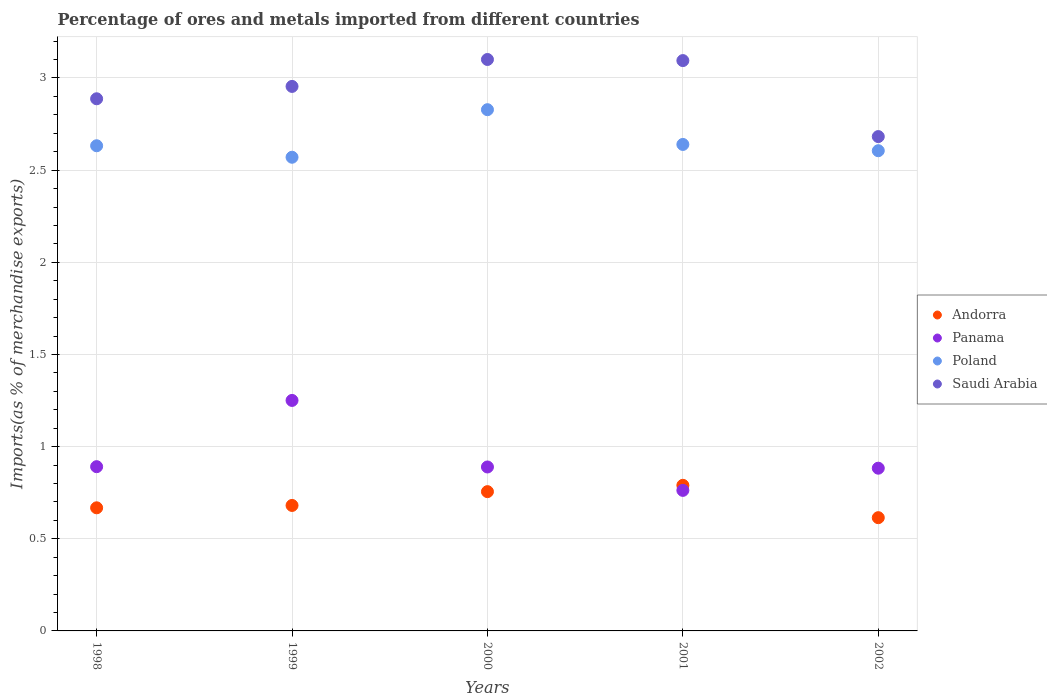What is the percentage of imports to different countries in Andorra in 2000?
Offer a terse response. 0.76. Across all years, what is the maximum percentage of imports to different countries in Saudi Arabia?
Offer a terse response. 3.1. Across all years, what is the minimum percentage of imports to different countries in Panama?
Offer a terse response. 0.76. In which year was the percentage of imports to different countries in Panama maximum?
Ensure brevity in your answer.  1999. What is the total percentage of imports to different countries in Poland in the graph?
Your response must be concise. 13.28. What is the difference between the percentage of imports to different countries in Andorra in 1999 and that in 2002?
Your answer should be compact. 0.07. What is the difference between the percentage of imports to different countries in Saudi Arabia in 1998 and the percentage of imports to different countries in Panama in 2002?
Offer a terse response. 2. What is the average percentage of imports to different countries in Saudi Arabia per year?
Keep it short and to the point. 2.94. In the year 2000, what is the difference between the percentage of imports to different countries in Panama and percentage of imports to different countries in Saudi Arabia?
Offer a terse response. -2.21. In how many years, is the percentage of imports to different countries in Poland greater than 2.5 %?
Your answer should be compact. 5. What is the ratio of the percentage of imports to different countries in Andorra in 1999 to that in 2000?
Your response must be concise. 0.9. Is the percentage of imports to different countries in Andorra in 2000 less than that in 2002?
Provide a short and direct response. No. What is the difference between the highest and the second highest percentage of imports to different countries in Poland?
Make the answer very short. 0.19. What is the difference between the highest and the lowest percentage of imports to different countries in Panama?
Offer a very short reply. 0.49. In how many years, is the percentage of imports to different countries in Panama greater than the average percentage of imports to different countries in Panama taken over all years?
Make the answer very short. 1. How many dotlines are there?
Give a very brief answer. 4. How many years are there in the graph?
Ensure brevity in your answer.  5. What is the difference between two consecutive major ticks on the Y-axis?
Your answer should be very brief. 0.5. Does the graph contain any zero values?
Offer a terse response. No. Does the graph contain grids?
Provide a short and direct response. Yes. Where does the legend appear in the graph?
Make the answer very short. Center right. How many legend labels are there?
Give a very brief answer. 4. What is the title of the graph?
Provide a short and direct response. Percentage of ores and metals imported from different countries. Does "Somalia" appear as one of the legend labels in the graph?
Offer a very short reply. No. What is the label or title of the X-axis?
Your answer should be very brief. Years. What is the label or title of the Y-axis?
Keep it short and to the point. Imports(as % of merchandise exports). What is the Imports(as % of merchandise exports) in Andorra in 1998?
Your answer should be very brief. 0.67. What is the Imports(as % of merchandise exports) of Panama in 1998?
Your answer should be very brief. 0.89. What is the Imports(as % of merchandise exports) of Poland in 1998?
Your response must be concise. 2.63. What is the Imports(as % of merchandise exports) of Saudi Arabia in 1998?
Offer a very short reply. 2.89. What is the Imports(as % of merchandise exports) in Andorra in 1999?
Your response must be concise. 0.68. What is the Imports(as % of merchandise exports) in Panama in 1999?
Your answer should be compact. 1.25. What is the Imports(as % of merchandise exports) in Poland in 1999?
Make the answer very short. 2.57. What is the Imports(as % of merchandise exports) in Saudi Arabia in 1999?
Provide a succinct answer. 2.95. What is the Imports(as % of merchandise exports) of Andorra in 2000?
Your response must be concise. 0.76. What is the Imports(as % of merchandise exports) in Panama in 2000?
Your answer should be compact. 0.89. What is the Imports(as % of merchandise exports) in Poland in 2000?
Provide a short and direct response. 2.83. What is the Imports(as % of merchandise exports) of Saudi Arabia in 2000?
Provide a succinct answer. 3.1. What is the Imports(as % of merchandise exports) of Andorra in 2001?
Your answer should be compact. 0.79. What is the Imports(as % of merchandise exports) in Panama in 2001?
Offer a terse response. 0.76. What is the Imports(as % of merchandise exports) in Poland in 2001?
Ensure brevity in your answer.  2.64. What is the Imports(as % of merchandise exports) in Saudi Arabia in 2001?
Provide a short and direct response. 3.09. What is the Imports(as % of merchandise exports) of Andorra in 2002?
Ensure brevity in your answer.  0.61. What is the Imports(as % of merchandise exports) in Panama in 2002?
Your answer should be very brief. 0.88. What is the Imports(as % of merchandise exports) in Poland in 2002?
Keep it short and to the point. 2.61. What is the Imports(as % of merchandise exports) in Saudi Arabia in 2002?
Your answer should be compact. 2.68. Across all years, what is the maximum Imports(as % of merchandise exports) of Andorra?
Your answer should be very brief. 0.79. Across all years, what is the maximum Imports(as % of merchandise exports) in Panama?
Offer a very short reply. 1.25. Across all years, what is the maximum Imports(as % of merchandise exports) in Poland?
Provide a succinct answer. 2.83. Across all years, what is the maximum Imports(as % of merchandise exports) in Saudi Arabia?
Your answer should be compact. 3.1. Across all years, what is the minimum Imports(as % of merchandise exports) of Andorra?
Offer a terse response. 0.61. Across all years, what is the minimum Imports(as % of merchandise exports) in Panama?
Ensure brevity in your answer.  0.76. Across all years, what is the minimum Imports(as % of merchandise exports) in Poland?
Ensure brevity in your answer.  2.57. Across all years, what is the minimum Imports(as % of merchandise exports) of Saudi Arabia?
Give a very brief answer. 2.68. What is the total Imports(as % of merchandise exports) in Andorra in the graph?
Offer a very short reply. 3.51. What is the total Imports(as % of merchandise exports) in Panama in the graph?
Keep it short and to the point. 4.68. What is the total Imports(as % of merchandise exports) in Poland in the graph?
Ensure brevity in your answer.  13.28. What is the total Imports(as % of merchandise exports) of Saudi Arabia in the graph?
Offer a terse response. 14.72. What is the difference between the Imports(as % of merchandise exports) of Andorra in 1998 and that in 1999?
Give a very brief answer. -0.01. What is the difference between the Imports(as % of merchandise exports) in Panama in 1998 and that in 1999?
Ensure brevity in your answer.  -0.36. What is the difference between the Imports(as % of merchandise exports) in Poland in 1998 and that in 1999?
Your response must be concise. 0.06. What is the difference between the Imports(as % of merchandise exports) in Saudi Arabia in 1998 and that in 1999?
Keep it short and to the point. -0.07. What is the difference between the Imports(as % of merchandise exports) in Andorra in 1998 and that in 2000?
Provide a succinct answer. -0.09. What is the difference between the Imports(as % of merchandise exports) of Panama in 1998 and that in 2000?
Give a very brief answer. 0. What is the difference between the Imports(as % of merchandise exports) of Poland in 1998 and that in 2000?
Ensure brevity in your answer.  -0.2. What is the difference between the Imports(as % of merchandise exports) in Saudi Arabia in 1998 and that in 2000?
Your answer should be very brief. -0.21. What is the difference between the Imports(as % of merchandise exports) in Andorra in 1998 and that in 2001?
Your answer should be compact. -0.12. What is the difference between the Imports(as % of merchandise exports) of Panama in 1998 and that in 2001?
Ensure brevity in your answer.  0.13. What is the difference between the Imports(as % of merchandise exports) of Poland in 1998 and that in 2001?
Your answer should be compact. -0.01. What is the difference between the Imports(as % of merchandise exports) in Saudi Arabia in 1998 and that in 2001?
Provide a succinct answer. -0.21. What is the difference between the Imports(as % of merchandise exports) in Andorra in 1998 and that in 2002?
Your response must be concise. 0.05. What is the difference between the Imports(as % of merchandise exports) of Panama in 1998 and that in 2002?
Your answer should be very brief. 0.01. What is the difference between the Imports(as % of merchandise exports) in Poland in 1998 and that in 2002?
Your answer should be very brief. 0.03. What is the difference between the Imports(as % of merchandise exports) of Saudi Arabia in 1998 and that in 2002?
Your answer should be compact. 0.21. What is the difference between the Imports(as % of merchandise exports) of Andorra in 1999 and that in 2000?
Your answer should be compact. -0.07. What is the difference between the Imports(as % of merchandise exports) in Panama in 1999 and that in 2000?
Provide a short and direct response. 0.36. What is the difference between the Imports(as % of merchandise exports) of Poland in 1999 and that in 2000?
Keep it short and to the point. -0.26. What is the difference between the Imports(as % of merchandise exports) of Saudi Arabia in 1999 and that in 2000?
Give a very brief answer. -0.15. What is the difference between the Imports(as % of merchandise exports) in Andorra in 1999 and that in 2001?
Offer a very short reply. -0.11. What is the difference between the Imports(as % of merchandise exports) in Panama in 1999 and that in 2001?
Offer a terse response. 0.49. What is the difference between the Imports(as % of merchandise exports) in Poland in 1999 and that in 2001?
Your answer should be very brief. -0.07. What is the difference between the Imports(as % of merchandise exports) of Saudi Arabia in 1999 and that in 2001?
Give a very brief answer. -0.14. What is the difference between the Imports(as % of merchandise exports) of Andorra in 1999 and that in 2002?
Provide a succinct answer. 0.07. What is the difference between the Imports(as % of merchandise exports) in Panama in 1999 and that in 2002?
Provide a succinct answer. 0.37. What is the difference between the Imports(as % of merchandise exports) in Poland in 1999 and that in 2002?
Provide a succinct answer. -0.04. What is the difference between the Imports(as % of merchandise exports) of Saudi Arabia in 1999 and that in 2002?
Your answer should be compact. 0.27. What is the difference between the Imports(as % of merchandise exports) of Andorra in 2000 and that in 2001?
Your answer should be compact. -0.03. What is the difference between the Imports(as % of merchandise exports) of Panama in 2000 and that in 2001?
Offer a terse response. 0.13. What is the difference between the Imports(as % of merchandise exports) of Poland in 2000 and that in 2001?
Keep it short and to the point. 0.19. What is the difference between the Imports(as % of merchandise exports) in Saudi Arabia in 2000 and that in 2001?
Your answer should be very brief. 0.01. What is the difference between the Imports(as % of merchandise exports) of Andorra in 2000 and that in 2002?
Your answer should be very brief. 0.14. What is the difference between the Imports(as % of merchandise exports) in Panama in 2000 and that in 2002?
Offer a terse response. 0.01. What is the difference between the Imports(as % of merchandise exports) in Poland in 2000 and that in 2002?
Ensure brevity in your answer.  0.22. What is the difference between the Imports(as % of merchandise exports) of Saudi Arabia in 2000 and that in 2002?
Offer a terse response. 0.42. What is the difference between the Imports(as % of merchandise exports) in Andorra in 2001 and that in 2002?
Provide a succinct answer. 0.18. What is the difference between the Imports(as % of merchandise exports) in Panama in 2001 and that in 2002?
Keep it short and to the point. -0.12. What is the difference between the Imports(as % of merchandise exports) in Poland in 2001 and that in 2002?
Your answer should be very brief. 0.03. What is the difference between the Imports(as % of merchandise exports) in Saudi Arabia in 2001 and that in 2002?
Offer a terse response. 0.41. What is the difference between the Imports(as % of merchandise exports) of Andorra in 1998 and the Imports(as % of merchandise exports) of Panama in 1999?
Give a very brief answer. -0.58. What is the difference between the Imports(as % of merchandise exports) of Andorra in 1998 and the Imports(as % of merchandise exports) of Poland in 1999?
Provide a short and direct response. -1.9. What is the difference between the Imports(as % of merchandise exports) in Andorra in 1998 and the Imports(as % of merchandise exports) in Saudi Arabia in 1999?
Keep it short and to the point. -2.29. What is the difference between the Imports(as % of merchandise exports) of Panama in 1998 and the Imports(as % of merchandise exports) of Poland in 1999?
Provide a short and direct response. -1.68. What is the difference between the Imports(as % of merchandise exports) in Panama in 1998 and the Imports(as % of merchandise exports) in Saudi Arabia in 1999?
Give a very brief answer. -2.06. What is the difference between the Imports(as % of merchandise exports) in Poland in 1998 and the Imports(as % of merchandise exports) in Saudi Arabia in 1999?
Give a very brief answer. -0.32. What is the difference between the Imports(as % of merchandise exports) of Andorra in 1998 and the Imports(as % of merchandise exports) of Panama in 2000?
Offer a terse response. -0.22. What is the difference between the Imports(as % of merchandise exports) in Andorra in 1998 and the Imports(as % of merchandise exports) in Poland in 2000?
Provide a short and direct response. -2.16. What is the difference between the Imports(as % of merchandise exports) of Andorra in 1998 and the Imports(as % of merchandise exports) of Saudi Arabia in 2000?
Provide a short and direct response. -2.43. What is the difference between the Imports(as % of merchandise exports) in Panama in 1998 and the Imports(as % of merchandise exports) in Poland in 2000?
Ensure brevity in your answer.  -1.94. What is the difference between the Imports(as % of merchandise exports) of Panama in 1998 and the Imports(as % of merchandise exports) of Saudi Arabia in 2000?
Provide a short and direct response. -2.21. What is the difference between the Imports(as % of merchandise exports) in Poland in 1998 and the Imports(as % of merchandise exports) in Saudi Arabia in 2000?
Keep it short and to the point. -0.47. What is the difference between the Imports(as % of merchandise exports) in Andorra in 1998 and the Imports(as % of merchandise exports) in Panama in 2001?
Your response must be concise. -0.09. What is the difference between the Imports(as % of merchandise exports) of Andorra in 1998 and the Imports(as % of merchandise exports) of Poland in 2001?
Give a very brief answer. -1.97. What is the difference between the Imports(as % of merchandise exports) of Andorra in 1998 and the Imports(as % of merchandise exports) of Saudi Arabia in 2001?
Your response must be concise. -2.43. What is the difference between the Imports(as % of merchandise exports) of Panama in 1998 and the Imports(as % of merchandise exports) of Poland in 2001?
Your response must be concise. -1.75. What is the difference between the Imports(as % of merchandise exports) in Panama in 1998 and the Imports(as % of merchandise exports) in Saudi Arabia in 2001?
Your response must be concise. -2.2. What is the difference between the Imports(as % of merchandise exports) of Poland in 1998 and the Imports(as % of merchandise exports) of Saudi Arabia in 2001?
Your answer should be compact. -0.46. What is the difference between the Imports(as % of merchandise exports) of Andorra in 1998 and the Imports(as % of merchandise exports) of Panama in 2002?
Ensure brevity in your answer.  -0.21. What is the difference between the Imports(as % of merchandise exports) of Andorra in 1998 and the Imports(as % of merchandise exports) of Poland in 2002?
Your response must be concise. -1.94. What is the difference between the Imports(as % of merchandise exports) of Andorra in 1998 and the Imports(as % of merchandise exports) of Saudi Arabia in 2002?
Provide a succinct answer. -2.01. What is the difference between the Imports(as % of merchandise exports) of Panama in 1998 and the Imports(as % of merchandise exports) of Poland in 2002?
Offer a very short reply. -1.71. What is the difference between the Imports(as % of merchandise exports) in Panama in 1998 and the Imports(as % of merchandise exports) in Saudi Arabia in 2002?
Provide a succinct answer. -1.79. What is the difference between the Imports(as % of merchandise exports) in Poland in 1998 and the Imports(as % of merchandise exports) in Saudi Arabia in 2002?
Your response must be concise. -0.05. What is the difference between the Imports(as % of merchandise exports) of Andorra in 1999 and the Imports(as % of merchandise exports) of Panama in 2000?
Ensure brevity in your answer.  -0.21. What is the difference between the Imports(as % of merchandise exports) in Andorra in 1999 and the Imports(as % of merchandise exports) in Poland in 2000?
Make the answer very short. -2.15. What is the difference between the Imports(as % of merchandise exports) in Andorra in 1999 and the Imports(as % of merchandise exports) in Saudi Arabia in 2000?
Your response must be concise. -2.42. What is the difference between the Imports(as % of merchandise exports) of Panama in 1999 and the Imports(as % of merchandise exports) of Poland in 2000?
Provide a succinct answer. -1.58. What is the difference between the Imports(as % of merchandise exports) of Panama in 1999 and the Imports(as % of merchandise exports) of Saudi Arabia in 2000?
Your answer should be very brief. -1.85. What is the difference between the Imports(as % of merchandise exports) in Poland in 1999 and the Imports(as % of merchandise exports) in Saudi Arabia in 2000?
Offer a very short reply. -0.53. What is the difference between the Imports(as % of merchandise exports) of Andorra in 1999 and the Imports(as % of merchandise exports) of Panama in 2001?
Make the answer very short. -0.08. What is the difference between the Imports(as % of merchandise exports) in Andorra in 1999 and the Imports(as % of merchandise exports) in Poland in 2001?
Make the answer very short. -1.96. What is the difference between the Imports(as % of merchandise exports) of Andorra in 1999 and the Imports(as % of merchandise exports) of Saudi Arabia in 2001?
Provide a short and direct response. -2.41. What is the difference between the Imports(as % of merchandise exports) in Panama in 1999 and the Imports(as % of merchandise exports) in Poland in 2001?
Keep it short and to the point. -1.39. What is the difference between the Imports(as % of merchandise exports) in Panama in 1999 and the Imports(as % of merchandise exports) in Saudi Arabia in 2001?
Your answer should be compact. -1.84. What is the difference between the Imports(as % of merchandise exports) of Poland in 1999 and the Imports(as % of merchandise exports) of Saudi Arabia in 2001?
Provide a succinct answer. -0.52. What is the difference between the Imports(as % of merchandise exports) of Andorra in 1999 and the Imports(as % of merchandise exports) of Panama in 2002?
Ensure brevity in your answer.  -0.2. What is the difference between the Imports(as % of merchandise exports) in Andorra in 1999 and the Imports(as % of merchandise exports) in Poland in 2002?
Give a very brief answer. -1.92. What is the difference between the Imports(as % of merchandise exports) in Andorra in 1999 and the Imports(as % of merchandise exports) in Saudi Arabia in 2002?
Your response must be concise. -2. What is the difference between the Imports(as % of merchandise exports) in Panama in 1999 and the Imports(as % of merchandise exports) in Poland in 2002?
Provide a succinct answer. -1.35. What is the difference between the Imports(as % of merchandise exports) of Panama in 1999 and the Imports(as % of merchandise exports) of Saudi Arabia in 2002?
Ensure brevity in your answer.  -1.43. What is the difference between the Imports(as % of merchandise exports) of Poland in 1999 and the Imports(as % of merchandise exports) of Saudi Arabia in 2002?
Offer a terse response. -0.11. What is the difference between the Imports(as % of merchandise exports) in Andorra in 2000 and the Imports(as % of merchandise exports) in Panama in 2001?
Keep it short and to the point. -0.01. What is the difference between the Imports(as % of merchandise exports) in Andorra in 2000 and the Imports(as % of merchandise exports) in Poland in 2001?
Make the answer very short. -1.88. What is the difference between the Imports(as % of merchandise exports) in Andorra in 2000 and the Imports(as % of merchandise exports) in Saudi Arabia in 2001?
Give a very brief answer. -2.34. What is the difference between the Imports(as % of merchandise exports) of Panama in 2000 and the Imports(as % of merchandise exports) of Poland in 2001?
Offer a very short reply. -1.75. What is the difference between the Imports(as % of merchandise exports) in Panama in 2000 and the Imports(as % of merchandise exports) in Saudi Arabia in 2001?
Give a very brief answer. -2.2. What is the difference between the Imports(as % of merchandise exports) in Poland in 2000 and the Imports(as % of merchandise exports) in Saudi Arabia in 2001?
Give a very brief answer. -0.27. What is the difference between the Imports(as % of merchandise exports) of Andorra in 2000 and the Imports(as % of merchandise exports) of Panama in 2002?
Ensure brevity in your answer.  -0.13. What is the difference between the Imports(as % of merchandise exports) of Andorra in 2000 and the Imports(as % of merchandise exports) of Poland in 2002?
Your answer should be compact. -1.85. What is the difference between the Imports(as % of merchandise exports) in Andorra in 2000 and the Imports(as % of merchandise exports) in Saudi Arabia in 2002?
Your answer should be compact. -1.93. What is the difference between the Imports(as % of merchandise exports) in Panama in 2000 and the Imports(as % of merchandise exports) in Poland in 2002?
Keep it short and to the point. -1.72. What is the difference between the Imports(as % of merchandise exports) of Panama in 2000 and the Imports(as % of merchandise exports) of Saudi Arabia in 2002?
Keep it short and to the point. -1.79. What is the difference between the Imports(as % of merchandise exports) in Poland in 2000 and the Imports(as % of merchandise exports) in Saudi Arabia in 2002?
Make the answer very short. 0.15. What is the difference between the Imports(as % of merchandise exports) in Andorra in 2001 and the Imports(as % of merchandise exports) in Panama in 2002?
Provide a short and direct response. -0.09. What is the difference between the Imports(as % of merchandise exports) in Andorra in 2001 and the Imports(as % of merchandise exports) in Poland in 2002?
Your answer should be very brief. -1.82. What is the difference between the Imports(as % of merchandise exports) of Andorra in 2001 and the Imports(as % of merchandise exports) of Saudi Arabia in 2002?
Ensure brevity in your answer.  -1.89. What is the difference between the Imports(as % of merchandise exports) in Panama in 2001 and the Imports(as % of merchandise exports) in Poland in 2002?
Make the answer very short. -1.84. What is the difference between the Imports(as % of merchandise exports) in Panama in 2001 and the Imports(as % of merchandise exports) in Saudi Arabia in 2002?
Offer a terse response. -1.92. What is the difference between the Imports(as % of merchandise exports) in Poland in 2001 and the Imports(as % of merchandise exports) in Saudi Arabia in 2002?
Your response must be concise. -0.04. What is the average Imports(as % of merchandise exports) of Andorra per year?
Your answer should be very brief. 0.7. What is the average Imports(as % of merchandise exports) of Panama per year?
Your answer should be compact. 0.94. What is the average Imports(as % of merchandise exports) of Poland per year?
Give a very brief answer. 2.65. What is the average Imports(as % of merchandise exports) in Saudi Arabia per year?
Offer a terse response. 2.94. In the year 1998, what is the difference between the Imports(as % of merchandise exports) in Andorra and Imports(as % of merchandise exports) in Panama?
Provide a short and direct response. -0.22. In the year 1998, what is the difference between the Imports(as % of merchandise exports) in Andorra and Imports(as % of merchandise exports) in Poland?
Offer a terse response. -1.96. In the year 1998, what is the difference between the Imports(as % of merchandise exports) of Andorra and Imports(as % of merchandise exports) of Saudi Arabia?
Keep it short and to the point. -2.22. In the year 1998, what is the difference between the Imports(as % of merchandise exports) in Panama and Imports(as % of merchandise exports) in Poland?
Offer a very short reply. -1.74. In the year 1998, what is the difference between the Imports(as % of merchandise exports) of Panama and Imports(as % of merchandise exports) of Saudi Arabia?
Offer a very short reply. -2. In the year 1998, what is the difference between the Imports(as % of merchandise exports) of Poland and Imports(as % of merchandise exports) of Saudi Arabia?
Keep it short and to the point. -0.25. In the year 1999, what is the difference between the Imports(as % of merchandise exports) of Andorra and Imports(as % of merchandise exports) of Panama?
Keep it short and to the point. -0.57. In the year 1999, what is the difference between the Imports(as % of merchandise exports) in Andorra and Imports(as % of merchandise exports) in Poland?
Your answer should be very brief. -1.89. In the year 1999, what is the difference between the Imports(as % of merchandise exports) of Andorra and Imports(as % of merchandise exports) of Saudi Arabia?
Offer a very short reply. -2.27. In the year 1999, what is the difference between the Imports(as % of merchandise exports) in Panama and Imports(as % of merchandise exports) in Poland?
Ensure brevity in your answer.  -1.32. In the year 1999, what is the difference between the Imports(as % of merchandise exports) of Panama and Imports(as % of merchandise exports) of Saudi Arabia?
Your answer should be very brief. -1.7. In the year 1999, what is the difference between the Imports(as % of merchandise exports) in Poland and Imports(as % of merchandise exports) in Saudi Arabia?
Provide a succinct answer. -0.38. In the year 2000, what is the difference between the Imports(as % of merchandise exports) of Andorra and Imports(as % of merchandise exports) of Panama?
Provide a short and direct response. -0.13. In the year 2000, what is the difference between the Imports(as % of merchandise exports) in Andorra and Imports(as % of merchandise exports) in Poland?
Ensure brevity in your answer.  -2.07. In the year 2000, what is the difference between the Imports(as % of merchandise exports) of Andorra and Imports(as % of merchandise exports) of Saudi Arabia?
Ensure brevity in your answer.  -2.34. In the year 2000, what is the difference between the Imports(as % of merchandise exports) of Panama and Imports(as % of merchandise exports) of Poland?
Make the answer very short. -1.94. In the year 2000, what is the difference between the Imports(as % of merchandise exports) of Panama and Imports(as % of merchandise exports) of Saudi Arabia?
Offer a terse response. -2.21. In the year 2000, what is the difference between the Imports(as % of merchandise exports) in Poland and Imports(as % of merchandise exports) in Saudi Arabia?
Provide a short and direct response. -0.27. In the year 2001, what is the difference between the Imports(as % of merchandise exports) of Andorra and Imports(as % of merchandise exports) of Panama?
Keep it short and to the point. 0.03. In the year 2001, what is the difference between the Imports(as % of merchandise exports) in Andorra and Imports(as % of merchandise exports) in Poland?
Provide a succinct answer. -1.85. In the year 2001, what is the difference between the Imports(as % of merchandise exports) of Andorra and Imports(as % of merchandise exports) of Saudi Arabia?
Make the answer very short. -2.3. In the year 2001, what is the difference between the Imports(as % of merchandise exports) in Panama and Imports(as % of merchandise exports) in Poland?
Make the answer very short. -1.88. In the year 2001, what is the difference between the Imports(as % of merchandise exports) of Panama and Imports(as % of merchandise exports) of Saudi Arabia?
Your response must be concise. -2.33. In the year 2001, what is the difference between the Imports(as % of merchandise exports) of Poland and Imports(as % of merchandise exports) of Saudi Arabia?
Keep it short and to the point. -0.46. In the year 2002, what is the difference between the Imports(as % of merchandise exports) in Andorra and Imports(as % of merchandise exports) in Panama?
Your answer should be very brief. -0.27. In the year 2002, what is the difference between the Imports(as % of merchandise exports) of Andorra and Imports(as % of merchandise exports) of Poland?
Give a very brief answer. -1.99. In the year 2002, what is the difference between the Imports(as % of merchandise exports) of Andorra and Imports(as % of merchandise exports) of Saudi Arabia?
Ensure brevity in your answer.  -2.07. In the year 2002, what is the difference between the Imports(as % of merchandise exports) in Panama and Imports(as % of merchandise exports) in Poland?
Provide a succinct answer. -1.72. In the year 2002, what is the difference between the Imports(as % of merchandise exports) of Panama and Imports(as % of merchandise exports) of Saudi Arabia?
Offer a very short reply. -1.8. In the year 2002, what is the difference between the Imports(as % of merchandise exports) in Poland and Imports(as % of merchandise exports) in Saudi Arabia?
Offer a terse response. -0.08. What is the ratio of the Imports(as % of merchandise exports) in Andorra in 1998 to that in 1999?
Make the answer very short. 0.98. What is the ratio of the Imports(as % of merchandise exports) in Panama in 1998 to that in 1999?
Ensure brevity in your answer.  0.71. What is the ratio of the Imports(as % of merchandise exports) in Poland in 1998 to that in 1999?
Your response must be concise. 1.02. What is the ratio of the Imports(as % of merchandise exports) of Saudi Arabia in 1998 to that in 1999?
Provide a succinct answer. 0.98. What is the ratio of the Imports(as % of merchandise exports) in Andorra in 1998 to that in 2000?
Give a very brief answer. 0.88. What is the ratio of the Imports(as % of merchandise exports) of Panama in 1998 to that in 2000?
Offer a terse response. 1. What is the ratio of the Imports(as % of merchandise exports) of Poland in 1998 to that in 2000?
Keep it short and to the point. 0.93. What is the ratio of the Imports(as % of merchandise exports) in Saudi Arabia in 1998 to that in 2000?
Ensure brevity in your answer.  0.93. What is the ratio of the Imports(as % of merchandise exports) in Andorra in 1998 to that in 2001?
Your response must be concise. 0.85. What is the ratio of the Imports(as % of merchandise exports) in Panama in 1998 to that in 2001?
Give a very brief answer. 1.17. What is the ratio of the Imports(as % of merchandise exports) in Saudi Arabia in 1998 to that in 2001?
Offer a terse response. 0.93. What is the ratio of the Imports(as % of merchandise exports) in Andorra in 1998 to that in 2002?
Your response must be concise. 1.09. What is the ratio of the Imports(as % of merchandise exports) of Panama in 1998 to that in 2002?
Offer a very short reply. 1.01. What is the ratio of the Imports(as % of merchandise exports) in Poland in 1998 to that in 2002?
Offer a very short reply. 1.01. What is the ratio of the Imports(as % of merchandise exports) in Saudi Arabia in 1998 to that in 2002?
Offer a very short reply. 1.08. What is the ratio of the Imports(as % of merchandise exports) in Andorra in 1999 to that in 2000?
Ensure brevity in your answer.  0.9. What is the ratio of the Imports(as % of merchandise exports) of Panama in 1999 to that in 2000?
Offer a terse response. 1.41. What is the ratio of the Imports(as % of merchandise exports) in Poland in 1999 to that in 2000?
Provide a succinct answer. 0.91. What is the ratio of the Imports(as % of merchandise exports) in Saudi Arabia in 1999 to that in 2000?
Ensure brevity in your answer.  0.95. What is the ratio of the Imports(as % of merchandise exports) of Andorra in 1999 to that in 2001?
Provide a succinct answer. 0.86. What is the ratio of the Imports(as % of merchandise exports) in Panama in 1999 to that in 2001?
Ensure brevity in your answer.  1.64. What is the ratio of the Imports(as % of merchandise exports) in Poland in 1999 to that in 2001?
Provide a succinct answer. 0.97. What is the ratio of the Imports(as % of merchandise exports) of Saudi Arabia in 1999 to that in 2001?
Ensure brevity in your answer.  0.95. What is the ratio of the Imports(as % of merchandise exports) of Andorra in 1999 to that in 2002?
Your response must be concise. 1.11. What is the ratio of the Imports(as % of merchandise exports) in Panama in 1999 to that in 2002?
Offer a very short reply. 1.42. What is the ratio of the Imports(as % of merchandise exports) in Poland in 1999 to that in 2002?
Offer a very short reply. 0.99. What is the ratio of the Imports(as % of merchandise exports) in Saudi Arabia in 1999 to that in 2002?
Your answer should be very brief. 1.1. What is the ratio of the Imports(as % of merchandise exports) in Andorra in 2000 to that in 2001?
Your answer should be compact. 0.96. What is the ratio of the Imports(as % of merchandise exports) of Panama in 2000 to that in 2001?
Provide a succinct answer. 1.17. What is the ratio of the Imports(as % of merchandise exports) in Poland in 2000 to that in 2001?
Your answer should be compact. 1.07. What is the ratio of the Imports(as % of merchandise exports) of Andorra in 2000 to that in 2002?
Keep it short and to the point. 1.23. What is the ratio of the Imports(as % of merchandise exports) of Panama in 2000 to that in 2002?
Give a very brief answer. 1.01. What is the ratio of the Imports(as % of merchandise exports) in Poland in 2000 to that in 2002?
Your response must be concise. 1.09. What is the ratio of the Imports(as % of merchandise exports) in Saudi Arabia in 2000 to that in 2002?
Your response must be concise. 1.16. What is the ratio of the Imports(as % of merchandise exports) of Panama in 2001 to that in 2002?
Your answer should be compact. 0.86. What is the ratio of the Imports(as % of merchandise exports) in Poland in 2001 to that in 2002?
Provide a short and direct response. 1.01. What is the ratio of the Imports(as % of merchandise exports) in Saudi Arabia in 2001 to that in 2002?
Give a very brief answer. 1.15. What is the difference between the highest and the second highest Imports(as % of merchandise exports) in Andorra?
Provide a short and direct response. 0.03. What is the difference between the highest and the second highest Imports(as % of merchandise exports) in Panama?
Keep it short and to the point. 0.36. What is the difference between the highest and the second highest Imports(as % of merchandise exports) of Poland?
Your response must be concise. 0.19. What is the difference between the highest and the second highest Imports(as % of merchandise exports) of Saudi Arabia?
Ensure brevity in your answer.  0.01. What is the difference between the highest and the lowest Imports(as % of merchandise exports) of Andorra?
Your response must be concise. 0.18. What is the difference between the highest and the lowest Imports(as % of merchandise exports) in Panama?
Offer a terse response. 0.49. What is the difference between the highest and the lowest Imports(as % of merchandise exports) in Poland?
Provide a succinct answer. 0.26. What is the difference between the highest and the lowest Imports(as % of merchandise exports) of Saudi Arabia?
Offer a very short reply. 0.42. 